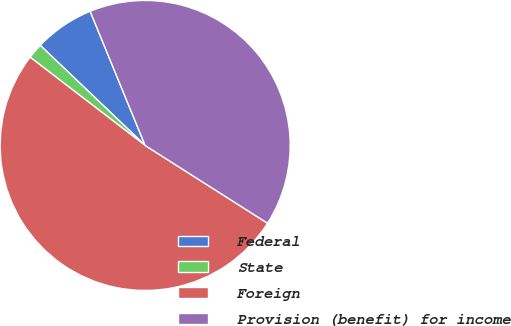Convert chart to OTSL. <chart><loc_0><loc_0><loc_500><loc_500><pie_chart><fcel>Federal<fcel>State<fcel>Foreign<fcel>Provision (benefit) for income<nl><fcel>6.68%<fcel>1.71%<fcel>51.4%<fcel>40.2%<nl></chart> 